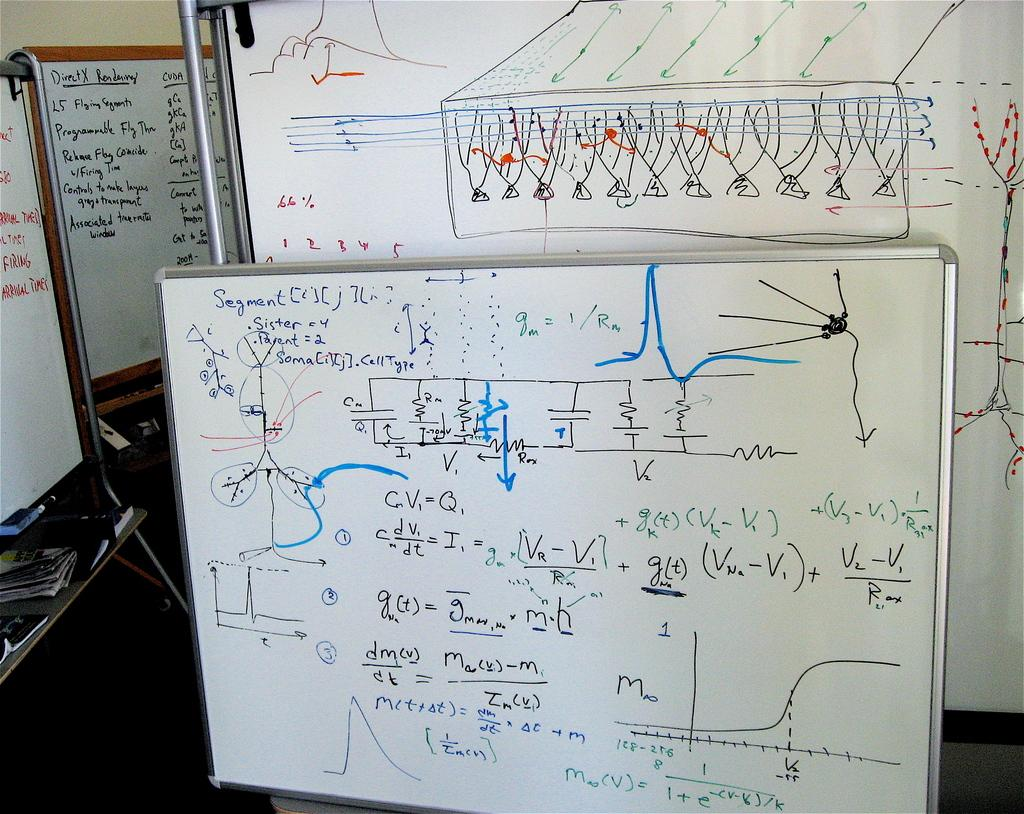<image>
Present a compact description of the photo's key features. Whiteboard that has the word "DirectX" on the top. 